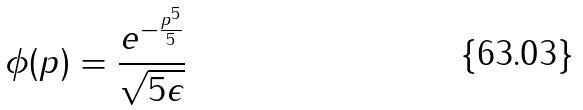Convert formula to latex. <formula><loc_0><loc_0><loc_500><loc_500>\phi ( p ) = \frac { e ^ { - \frac { p ^ { 5 } } { 5 } } } { \sqrt { 5 \epsilon } }</formula> 